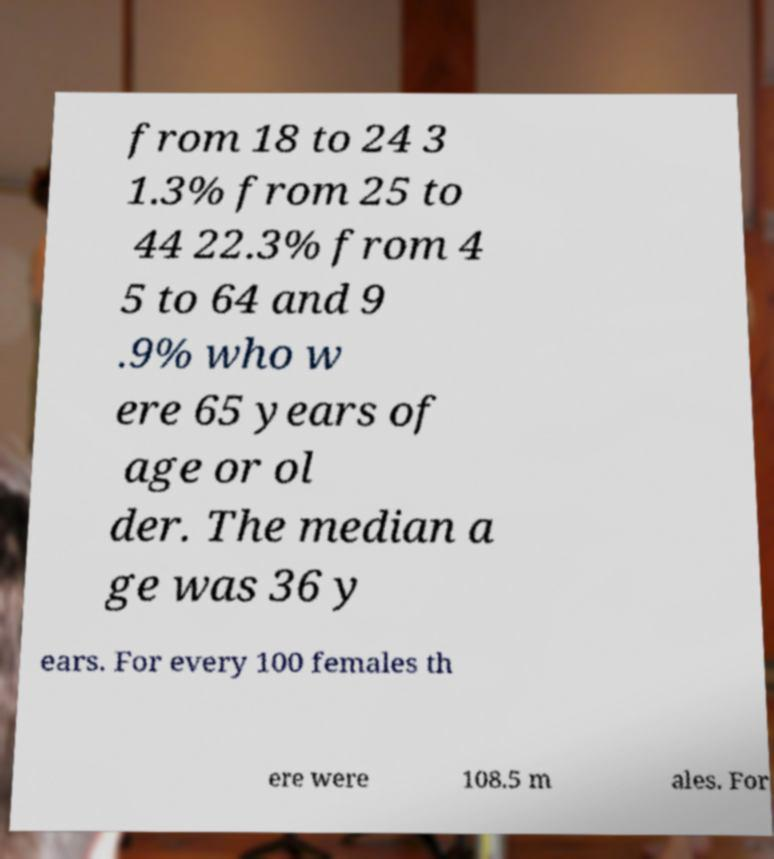What messages or text are displayed in this image? I need them in a readable, typed format. from 18 to 24 3 1.3% from 25 to 44 22.3% from 4 5 to 64 and 9 .9% who w ere 65 years of age or ol der. The median a ge was 36 y ears. For every 100 females th ere were 108.5 m ales. For 